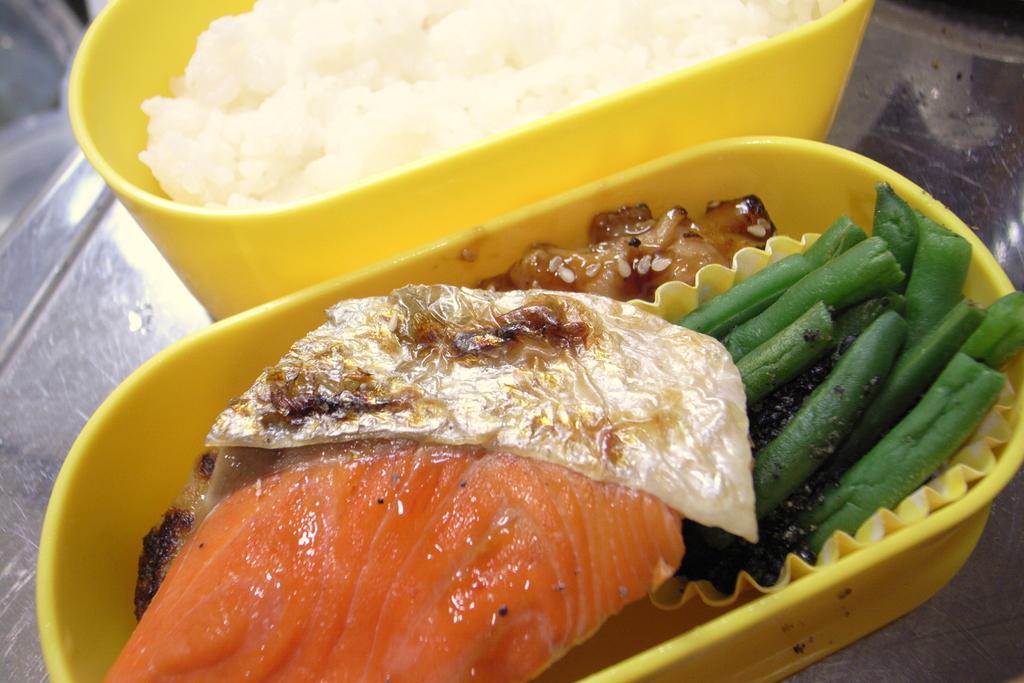Describe this image in one or two sentences. In this image we can see food items in the boxes on a platform. 